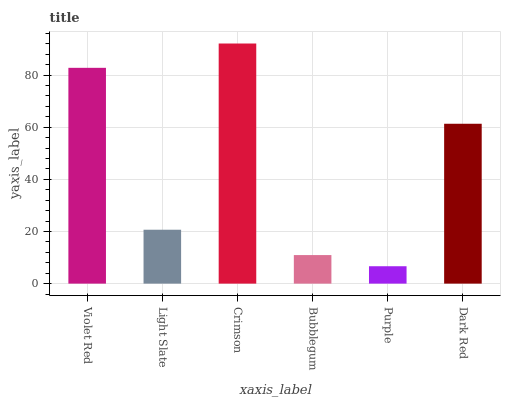Is Purple the minimum?
Answer yes or no. Yes. Is Crimson the maximum?
Answer yes or no. Yes. Is Light Slate the minimum?
Answer yes or no. No. Is Light Slate the maximum?
Answer yes or no. No. Is Violet Red greater than Light Slate?
Answer yes or no. Yes. Is Light Slate less than Violet Red?
Answer yes or no. Yes. Is Light Slate greater than Violet Red?
Answer yes or no. No. Is Violet Red less than Light Slate?
Answer yes or no. No. Is Dark Red the high median?
Answer yes or no. Yes. Is Light Slate the low median?
Answer yes or no. Yes. Is Light Slate the high median?
Answer yes or no. No. Is Bubblegum the low median?
Answer yes or no. No. 